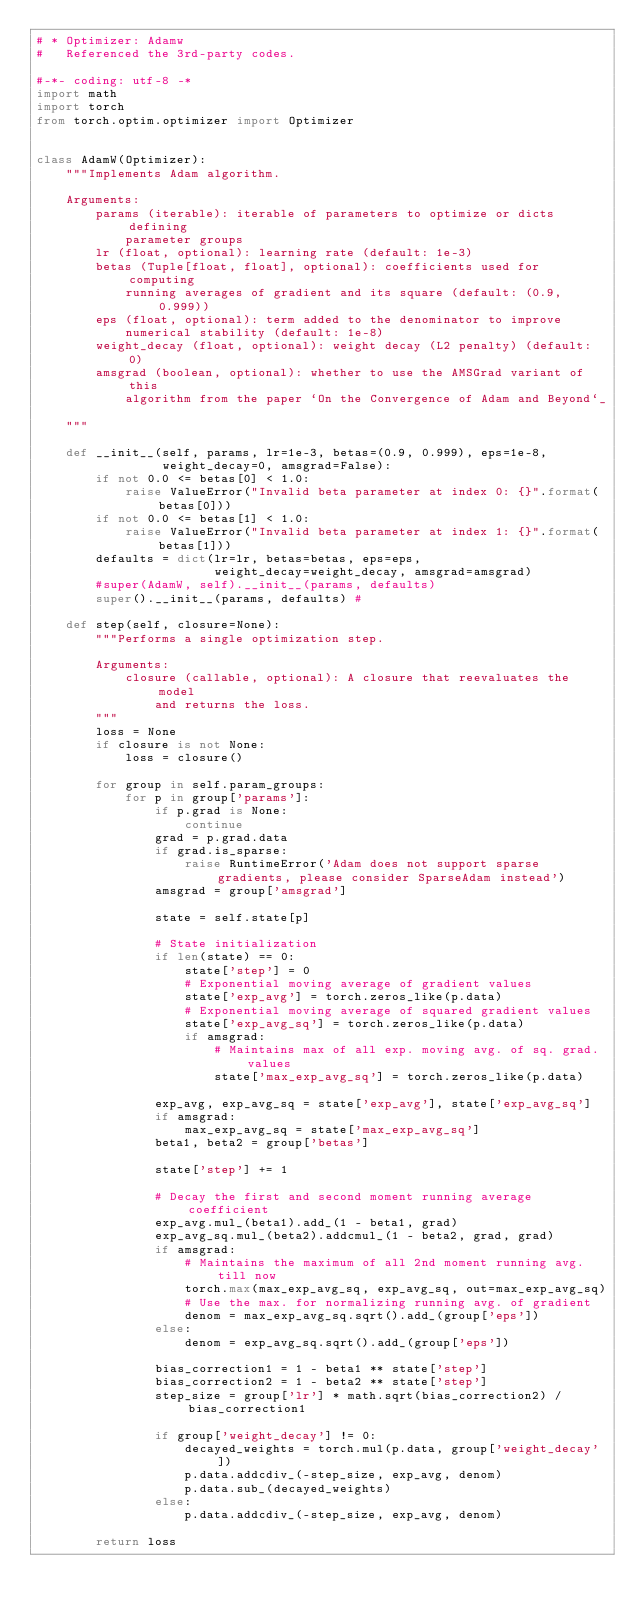<code> <loc_0><loc_0><loc_500><loc_500><_Python_># * Optimizer: Adamw
#   Referenced the 3rd-party codes.

#-*- coding: utf-8 -*
import math
import torch
from torch.optim.optimizer import Optimizer


class AdamW(Optimizer):
    """Implements Adam algorithm.

    Arguments:
        params (iterable): iterable of parameters to optimize or dicts defining
            parameter groups
        lr (float, optional): learning rate (default: 1e-3)
        betas (Tuple[float, float], optional): coefficients used for computing
            running averages of gradient and its square (default: (0.9, 0.999))
        eps (float, optional): term added to the denominator to improve
            numerical stability (default: 1e-8)
        weight_decay (float, optional): weight decay (L2 penalty) (default: 0)
        amsgrad (boolean, optional): whether to use the AMSGrad variant of this
            algorithm from the paper `On the Convergence of Adam and Beyond`_

    """

    def __init__(self, params, lr=1e-3, betas=(0.9, 0.999), eps=1e-8,
                 weight_decay=0, amsgrad=False):
        if not 0.0 <= betas[0] < 1.0:
            raise ValueError("Invalid beta parameter at index 0: {}".format(betas[0]))
        if not 0.0 <= betas[1] < 1.0:
            raise ValueError("Invalid beta parameter at index 1: {}".format(betas[1]))
        defaults = dict(lr=lr, betas=betas, eps=eps,
                        weight_decay=weight_decay, amsgrad=amsgrad)
        #super(AdamW, self).__init__(params, defaults)
        super().__init__(params, defaults) #

    def step(self, closure=None):
        """Performs a single optimization step.

        Arguments:
            closure (callable, optional): A closure that reevaluates the model
                and returns the loss.
        """
        loss = None
        if closure is not None:
            loss = closure()

        for group in self.param_groups:
            for p in group['params']:
                if p.grad is None:
                    continue
                grad = p.grad.data
                if grad.is_sparse:
                    raise RuntimeError('Adam does not support sparse gradients, please consider SparseAdam instead')
                amsgrad = group['amsgrad']

                state = self.state[p]

                # State initialization
                if len(state) == 0:
                    state['step'] = 0
                    # Exponential moving average of gradient values
                    state['exp_avg'] = torch.zeros_like(p.data)
                    # Exponential moving average of squared gradient values
                    state['exp_avg_sq'] = torch.zeros_like(p.data)
                    if amsgrad:
                        # Maintains max of all exp. moving avg. of sq. grad. values
                        state['max_exp_avg_sq'] = torch.zeros_like(p.data)

                exp_avg, exp_avg_sq = state['exp_avg'], state['exp_avg_sq']
                if amsgrad:
                    max_exp_avg_sq = state['max_exp_avg_sq']
                beta1, beta2 = group['betas']

                state['step'] += 1

                # Decay the first and second moment running average coefficient
                exp_avg.mul_(beta1).add_(1 - beta1, grad)
                exp_avg_sq.mul_(beta2).addcmul_(1 - beta2, grad, grad)
                if amsgrad:
                    # Maintains the maximum of all 2nd moment running avg. till now
                    torch.max(max_exp_avg_sq, exp_avg_sq, out=max_exp_avg_sq)
                    # Use the max. for normalizing running avg. of gradient
                    denom = max_exp_avg_sq.sqrt().add_(group['eps'])
                else:
                    denom = exp_avg_sq.sqrt().add_(group['eps'])

                bias_correction1 = 1 - beta1 ** state['step']
                bias_correction2 = 1 - beta2 ** state['step']
                step_size = group['lr'] * math.sqrt(bias_correction2) / bias_correction1

                if group['weight_decay'] != 0:
                    decayed_weights = torch.mul(p.data, group['weight_decay'])
                    p.data.addcdiv_(-step_size, exp_avg, denom)
                    p.data.sub_(decayed_weights)
                else:
                    p.data.addcdiv_(-step_size, exp_avg, denom)

        return loss
</code> 